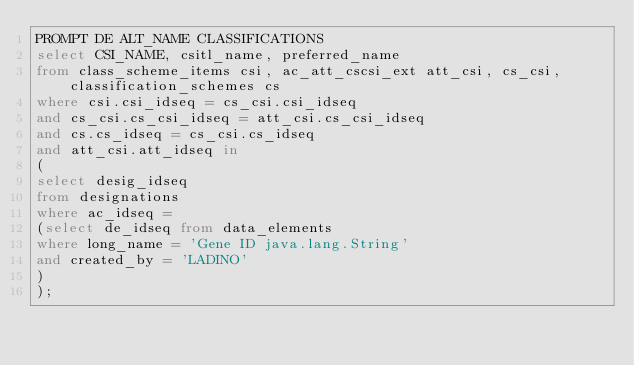<code> <loc_0><loc_0><loc_500><loc_500><_SQL_>PROMPT DE ALT_NAME CLASSIFICATIONS
select CSI_NAME, csitl_name, preferred_name
from class_scheme_items csi, ac_att_cscsi_ext att_csi, cs_csi, classification_schemes cs
where csi.csi_idseq = cs_csi.csi_idseq 
and cs_csi.cs_csi_idseq = att_csi.cs_csi_idseq
and cs.cs_idseq = cs_csi.cs_idseq
and att_csi.att_idseq in 
(
select desig_idseq
from designations
where ac_idseq = 
(select de_idseq from data_elements
where long_name = 'Gene ID java.lang.String'
and created_by = 'LADINO'
)
); 

</code> 